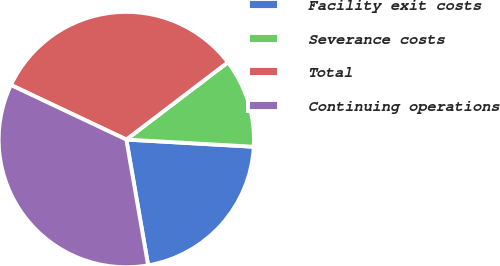Convert chart to OTSL. <chart><loc_0><loc_0><loc_500><loc_500><pie_chart><fcel>Facility exit costs<fcel>Severance costs<fcel>Total<fcel>Continuing operations<nl><fcel>21.37%<fcel>11.25%<fcel>32.62%<fcel>34.76%<nl></chart> 